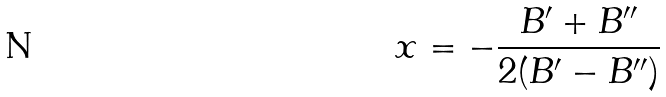Convert formula to latex. <formula><loc_0><loc_0><loc_500><loc_500>x = - \frac { B ^ { \prime } + B ^ { \prime \prime } } { 2 ( B ^ { \prime } - B ^ { \prime \prime } ) }</formula> 